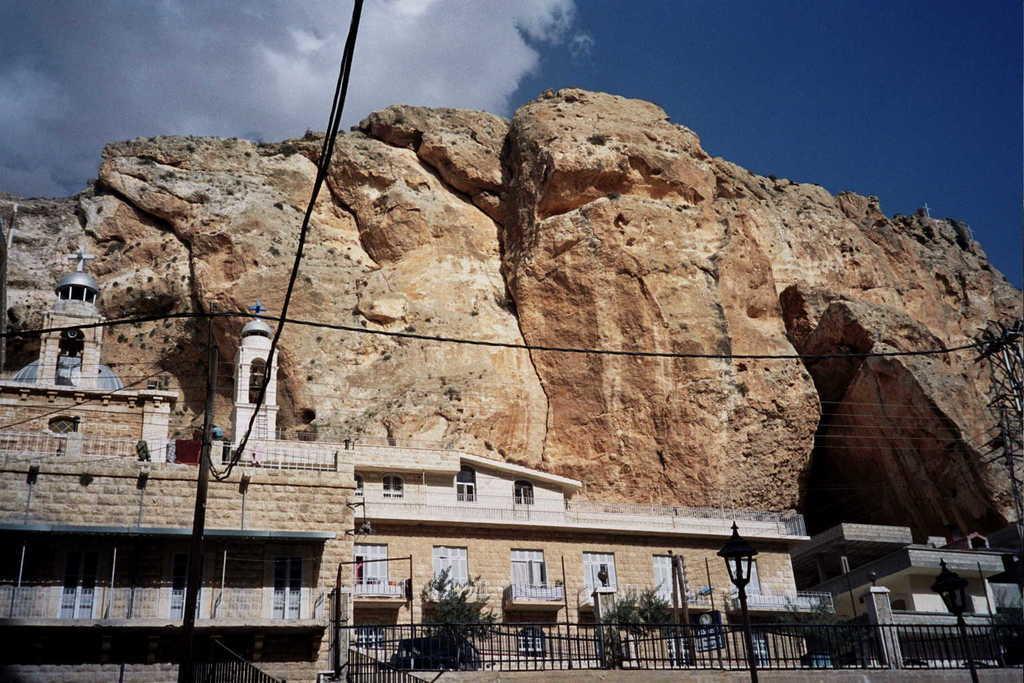Could you give a brief overview of what you see in this image? In this image I can see few light poles. In the background I can see the railing, few plants in green color, few buildings and I can also see the rock and the sky is in blue and white color. 